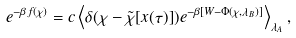Convert formula to latex. <formula><loc_0><loc_0><loc_500><loc_500>e ^ { - \beta f ( \chi ) } & = c \left \langle \delta ( \chi - \tilde { \chi } [ x ( \tau ) ] ) e ^ { - \beta [ W - \Phi ( \chi , \lambda _ { B } ) ] } \right \rangle _ { \lambda _ { A } } ,</formula> 